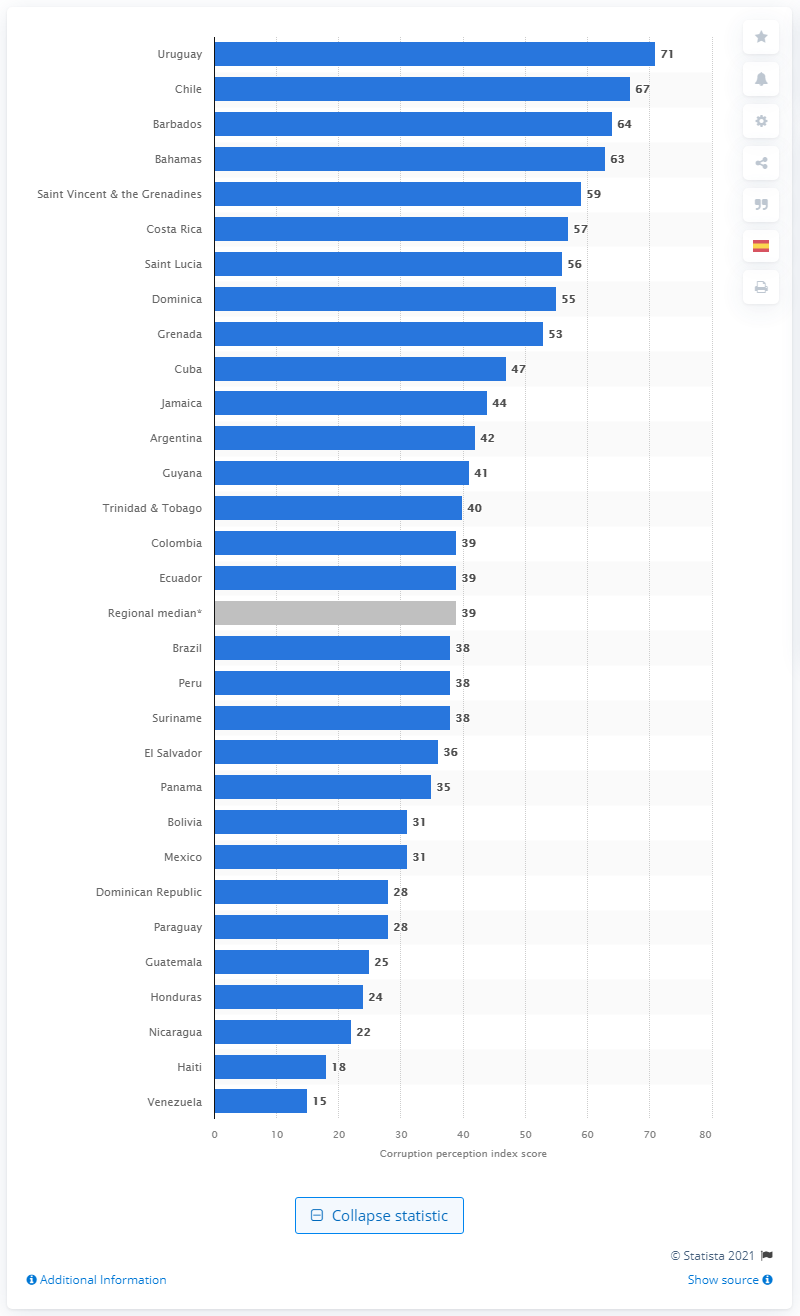List a handful of essential elements in this visual. Venezuela had a score of 15 on the Corruption Perception Index, reflecting a high level of corruption in the country. In 2021, Uruguay's Corruption Perception Index score was 71, indicating a moderate level of corruption in the country. Venezuela is the Latin American nation with the worst perceived level of corruption. Uruguay was declared the least corrupt country in Latin America and the Caribbean in 2020. 